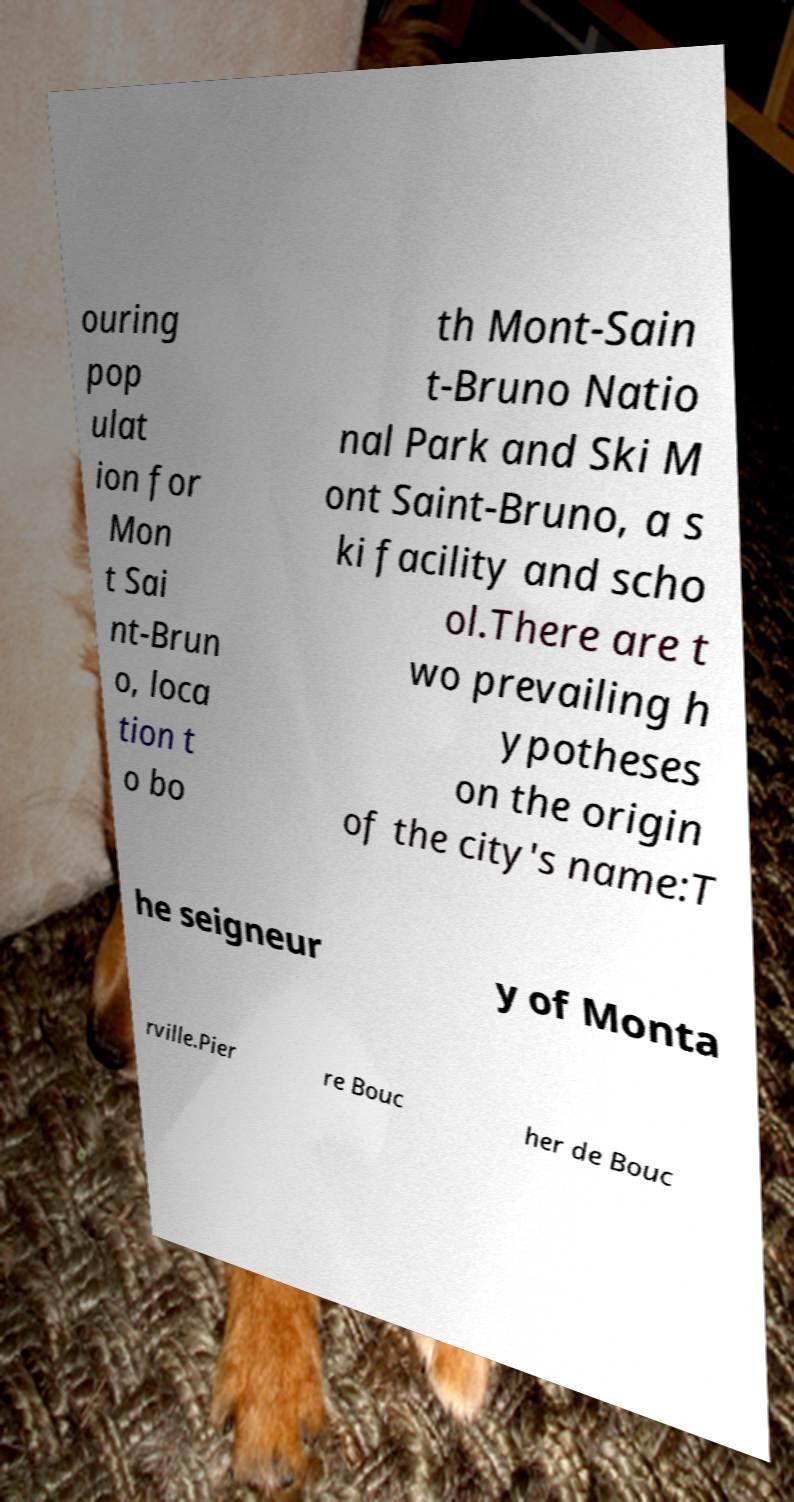Could you assist in decoding the text presented in this image and type it out clearly? ouring pop ulat ion for Mon t Sai nt-Brun o, loca tion t o bo th Mont-Sain t-Bruno Natio nal Park and Ski M ont Saint-Bruno, a s ki facility and scho ol.There are t wo prevailing h ypotheses on the origin of the city's name:T he seigneur y of Monta rville.Pier re Bouc her de Bouc 